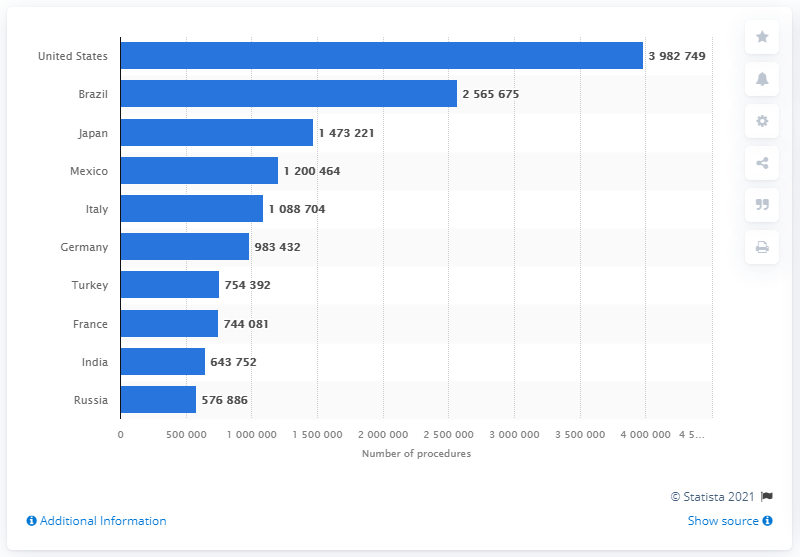Mention a couple of crucial points in this snapshot. Brazil had the second largest number of cosmetic procedures in 2019. 